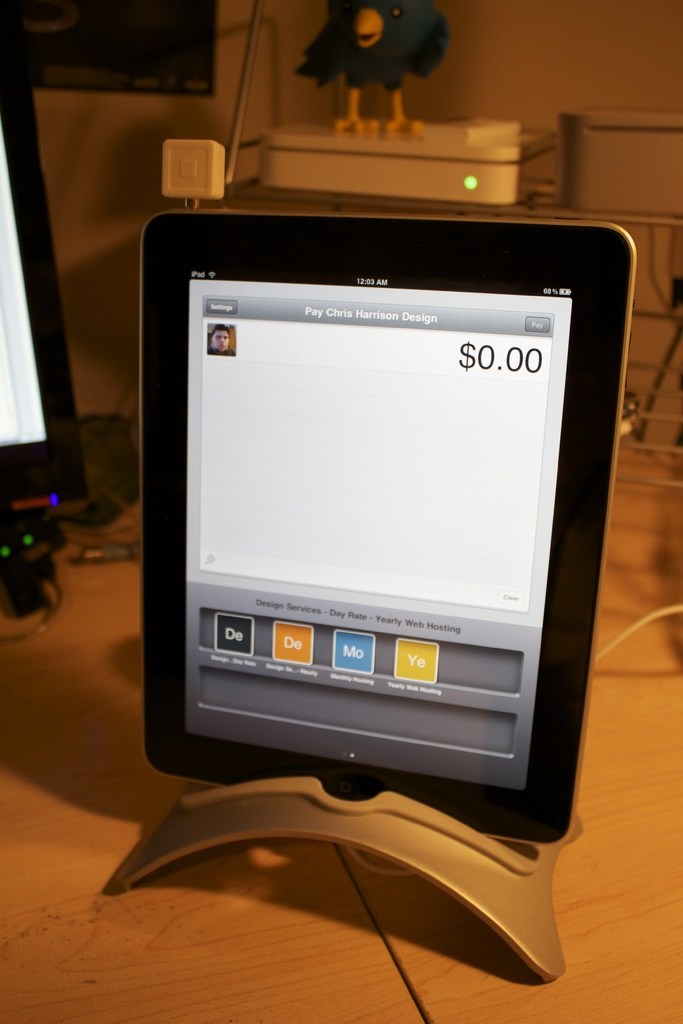What can you infer about the business based on the image? Based on the image, it appears to be a design-oriented business that offers flexible billing rates including day, monthly, and yearly options, possibly catering to varying needs of its customers. 